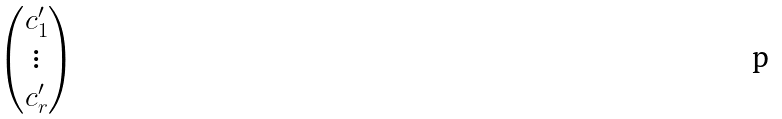<formula> <loc_0><loc_0><loc_500><loc_500>\begin{pmatrix} c _ { 1 } ^ { \prime } \\ \vdots \\ c _ { r } ^ { \prime } \end{pmatrix}</formula> 